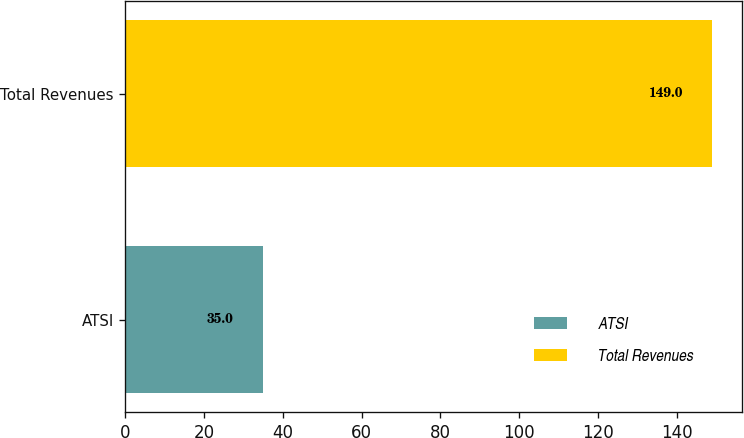Convert chart to OTSL. <chart><loc_0><loc_0><loc_500><loc_500><bar_chart><fcel>ATSI<fcel>Total Revenues<nl><fcel>35<fcel>149<nl></chart> 